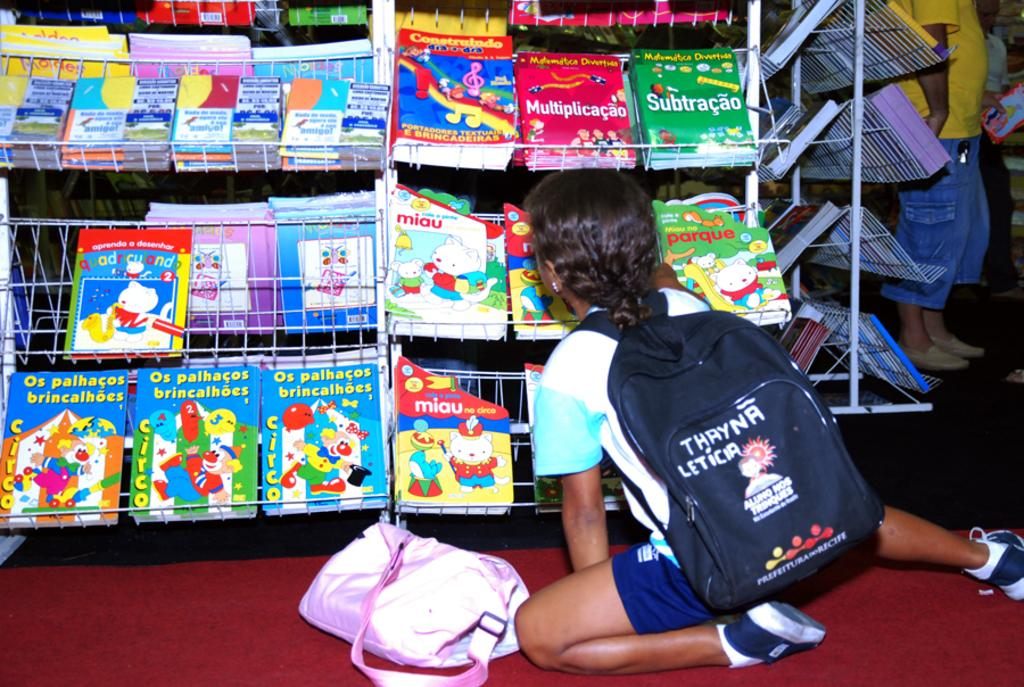<image>
Offer a succinct explanation of the picture presented. Little kid is sitting on the floor looking at different books 